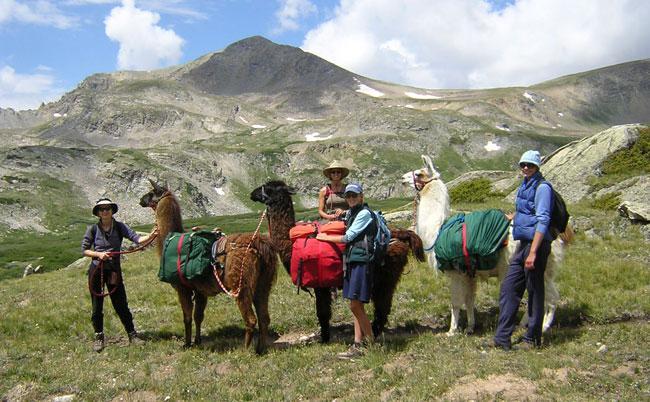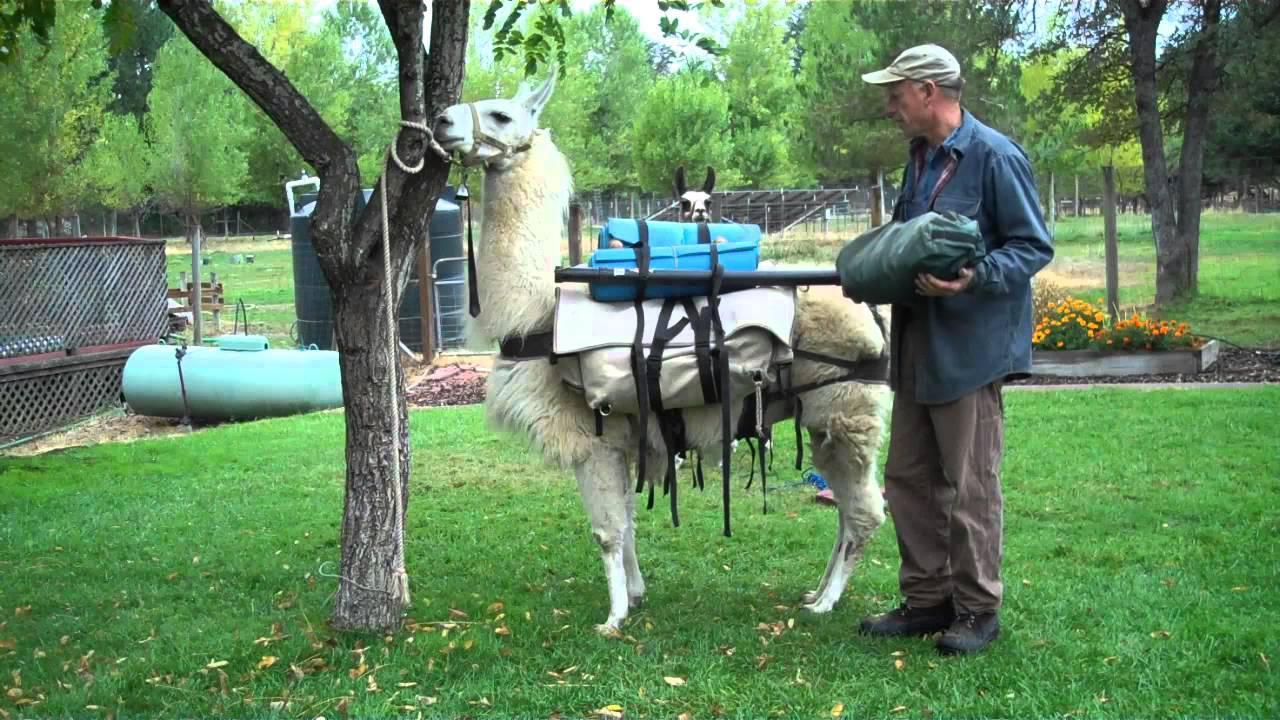The first image is the image on the left, the second image is the image on the right. For the images displayed, is the sentence "In one image, exactly one forward-facing person in sunglasses is standing on an overlook next to the front-end of a llama with its body turned leftward." factually correct? Answer yes or no. No. 